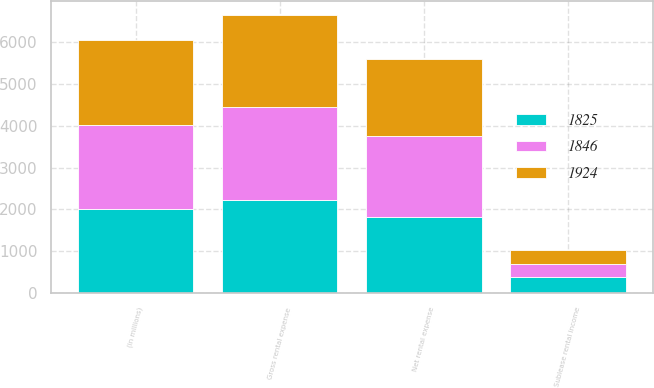Convert chart. <chart><loc_0><loc_0><loc_500><loc_500><stacked_bar_chart><ecel><fcel>(in millions)<fcel>Gross rental expense<fcel>Sublease rental income<fcel>Net rental expense<nl><fcel>1924<fcel>2013<fcel>2187<fcel>341<fcel>1846<nl><fcel>1846<fcel>2012<fcel>2212<fcel>288<fcel>1924<nl><fcel>1825<fcel>2011<fcel>2228<fcel>403<fcel>1825<nl></chart> 